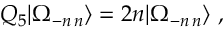<formula> <loc_0><loc_0><loc_500><loc_500>Q _ { 5 } | \Omega _ { - n \, n } \rangle = 2 n | \Omega _ { - n \, n } \rangle \ ,</formula> 